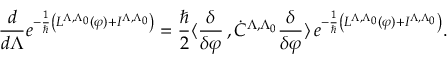<formula> <loc_0><loc_0><loc_500><loc_500>\frac { d } { d \Lambda } e ^ { - \frac { 1 } { } \left ( L ^ { \Lambda , \Lambda _ { 0 } } ( \varphi ) + I ^ { \Lambda , \Lambda _ { 0 } } \right ) } = \frac { } { 2 } \langle \frac { \delta } { \delta \varphi } \, , \dot { C } ^ { \Lambda , \Lambda _ { 0 } } \frac { \delta } { \delta \varphi } \rangle \, e ^ { - \frac { 1 } { } \left ( L ^ { \Lambda , \Lambda _ { 0 } } ( \varphi ) + I ^ { \Lambda , \Lambda _ { 0 } } \right ) } .</formula> 